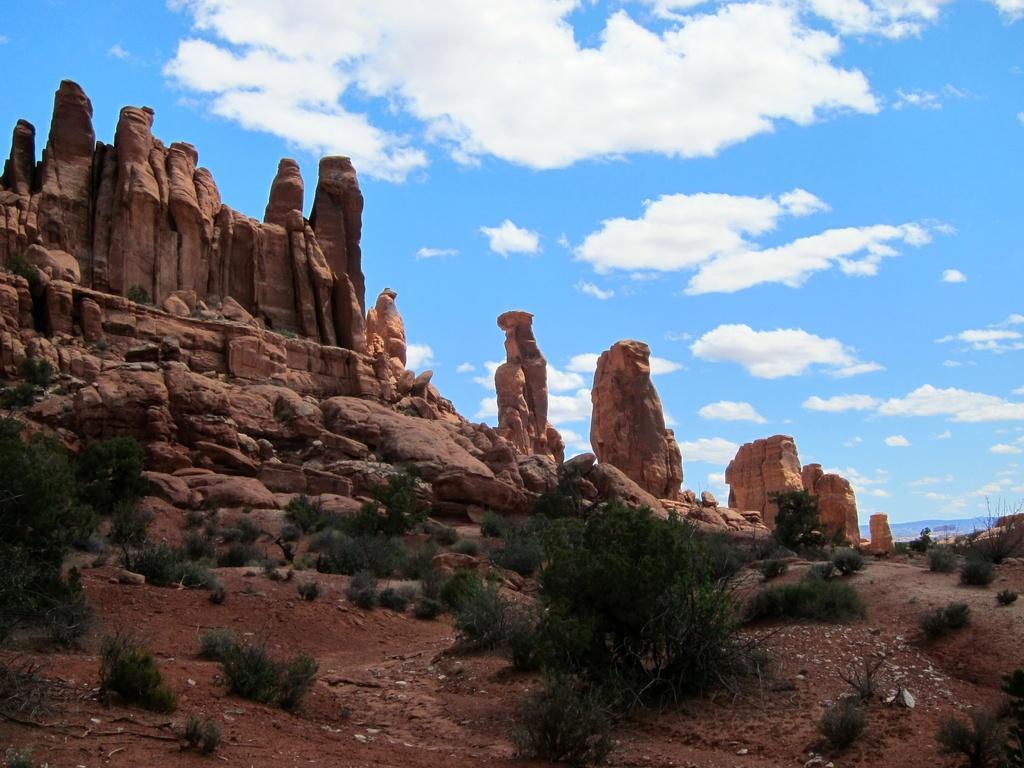How would you summarize this image in a sentence or two? Here we can see plants and rocks. In the background there is sky with clouds. 